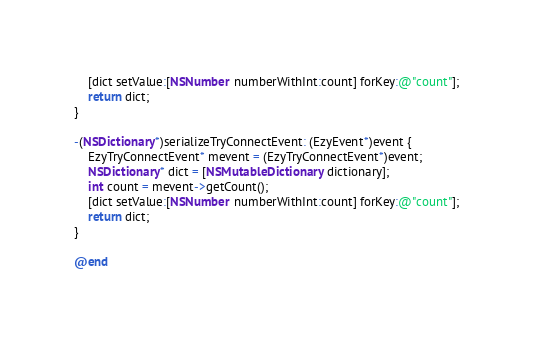Convert code to text. <code><loc_0><loc_0><loc_500><loc_500><_ObjectiveC_>    [dict setValue:[NSNumber numberWithInt:count] forKey:@"count"];
    return dict;
}

-(NSDictionary*)serializeTryConnectEvent: (EzyEvent*)event {
    EzyTryConnectEvent* mevent = (EzyTryConnectEvent*)event;
    NSDictionary* dict = [NSMutableDictionary dictionary];
    int count = mevent->getCount();
    [dict setValue:[NSNumber numberWithInt:count] forKey:@"count"];
    return dict;
}

@end
</code> 